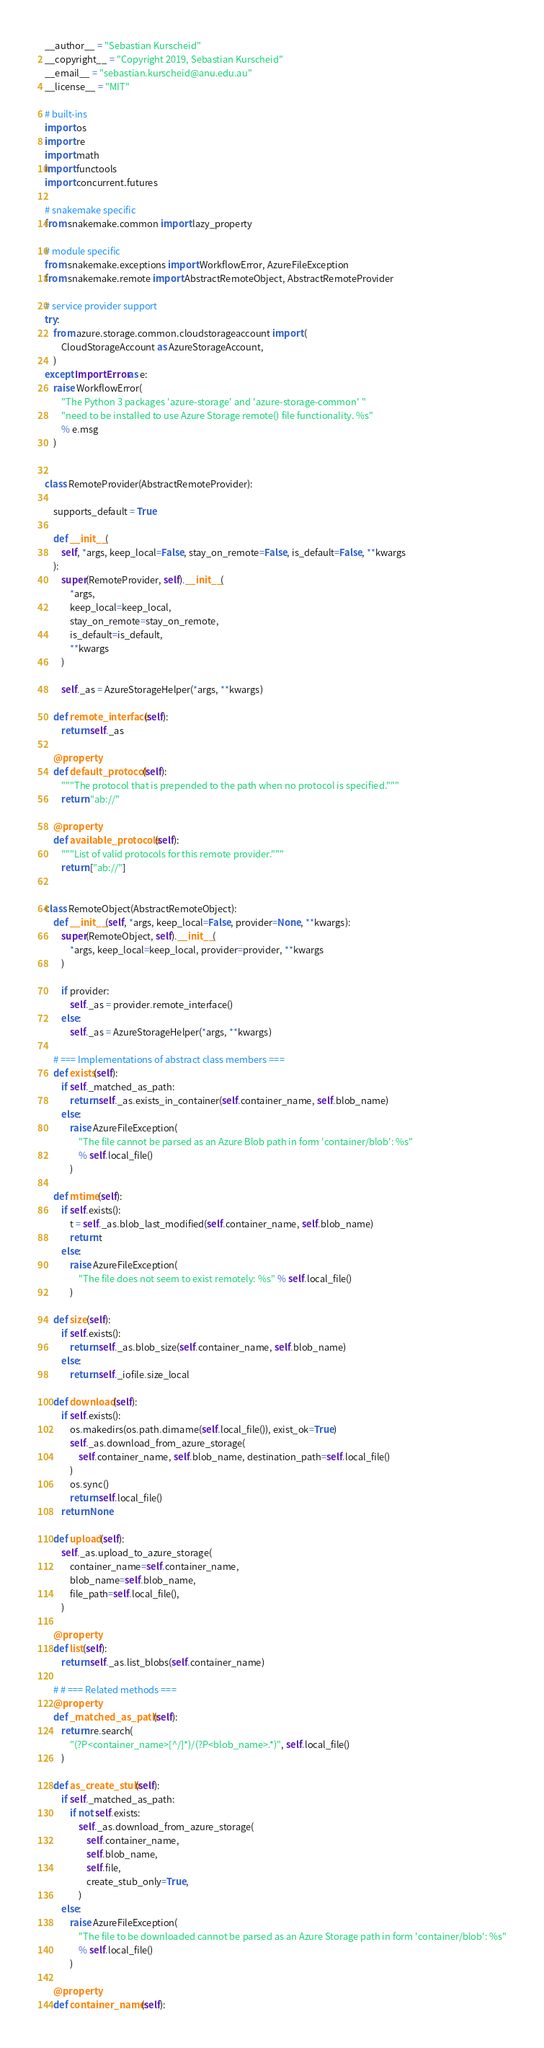<code> <loc_0><loc_0><loc_500><loc_500><_Python_>__author__ = "Sebastian Kurscheid"
__copyright__ = "Copyright 2019, Sebastian Kurscheid"
__email__ = "sebastian.kurscheid@anu.edu.au"
__license__ = "MIT"

# built-ins
import os
import re
import math
import functools
import concurrent.futures

# snakemake specific
from snakemake.common import lazy_property

# module specific
from snakemake.exceptions import WorkflowError, AzureFileException
from snakemake.remote import AbstractRemoteObject, AbstractRemoteProvider

# service provider support
try:
    from azure.storage.common.cloudstorageaccount import (
        CloudStorageAccount as AzureStorageAccount,
    )
except ImportError as e:
    raise WorkflowError(
        "The Python 3 packages 'azure-storage' and 'azure-storage-common' "
        "need to be installed to use Azure Storage remote() file functionality. %s"
        % e.msg
    )


class RemoteProvider(AbstractRemoteProvider):

    supports_default = True

    def __init__(
        self, *args, keep_local=False, stay_on_remote=False, is_default=False, **kwargs
    ):
        super(RemoteProvider, self).__init__(
            *args,
            keep_local=keep_local,
            stay_on_remote=stay_on_remote,
            is_default=is_default,
            **kwargs
        )

        self._as = AzureStorageHelper(*args, **kwargs)

    def remote_interface(self):
        return self._as

    @property
    def default_protocol(self):
        """The protocol that is prepended to the path when no protocol is specified."""
        return "ab://"

    @property
    def available_protocols(self):
        """List of valid protocols for this remote provider."""
        return ["ab://"]


class RemoteObject(AbstractRemoteObject):
    def __init__(self, *args, keep_local=False, provider=None, **kwargs):
        super(RemoteObject, self).__init__(
            *args, keep_local=keep_local, provider=provider, **kwargs
        )

        if provider:
            self._as = provider.remote_interface()
        else:
            self._as = AzureStorageHelper(*args, **kwargs)

    # === Implementations of abstract class members ===
    def exists(self):
        if self._matched_as_path:
            return self._as.exists_in_container(self.container_name, self.blob_name)
        else:
            raise AzureFileException(
                "The file cannot be parsed as an Azure Blob path in form 'container/blob': %s"
                % self.local_file()
            )

    def mtime(self):
        if self.exists():
            t = self._as.blob_last_modified(self.container_name, self.blob_name)
            return t
        else:
            raise AzureFileException(
                "The file does not seem to exist remotely: %s" % self.local_file()
            )

    def size(self):
        if self.exists():
            return self._as.blob_size(self.container_name, self.blob_name)
        else:
            return self._iofile.size_local

    def download(self):
        if self.exists():
            os.makedirs(os.path.dirname(self.local_file()), exist_ok=True)
            self._as.download_from_azure_storage(
                self.container_name, self.blob_name, destination_path=self.local_file()
            )
            os.sync()
            return self.local_file()
        return None

    def upload(self):
        self._as.upload_to_azure_storage(
            container_name=self.container_name,
            blob_name=self.blob_name,
            file_path=self.local_file(),
        )

    @property
    def list(self):
        return self._as.list_blobs(self.container_name)

    # # === Related methods ===
    @property
    def _matched_as_path(self):
        return re.search(
            "(?P<container_name>[^/]*)/(?P<blob_name>.*)", self.local_file()
        )

    def as_create_stub(self):
        if self._matched_as_path:
            if not self.exists:
                self._as.download_from_azure_storage(
                    self.container_name,
                    self.blob_name,
                    self.file,
                    create_stub_only=True,
                )
        else:
            raise AzureFileException(
                "The file to be downloaded cannot be parsed as an Azure Storage path in form 'container/blob': %s"
                % self.local_file()
            )

    @property
    def container_name(self):</code> 